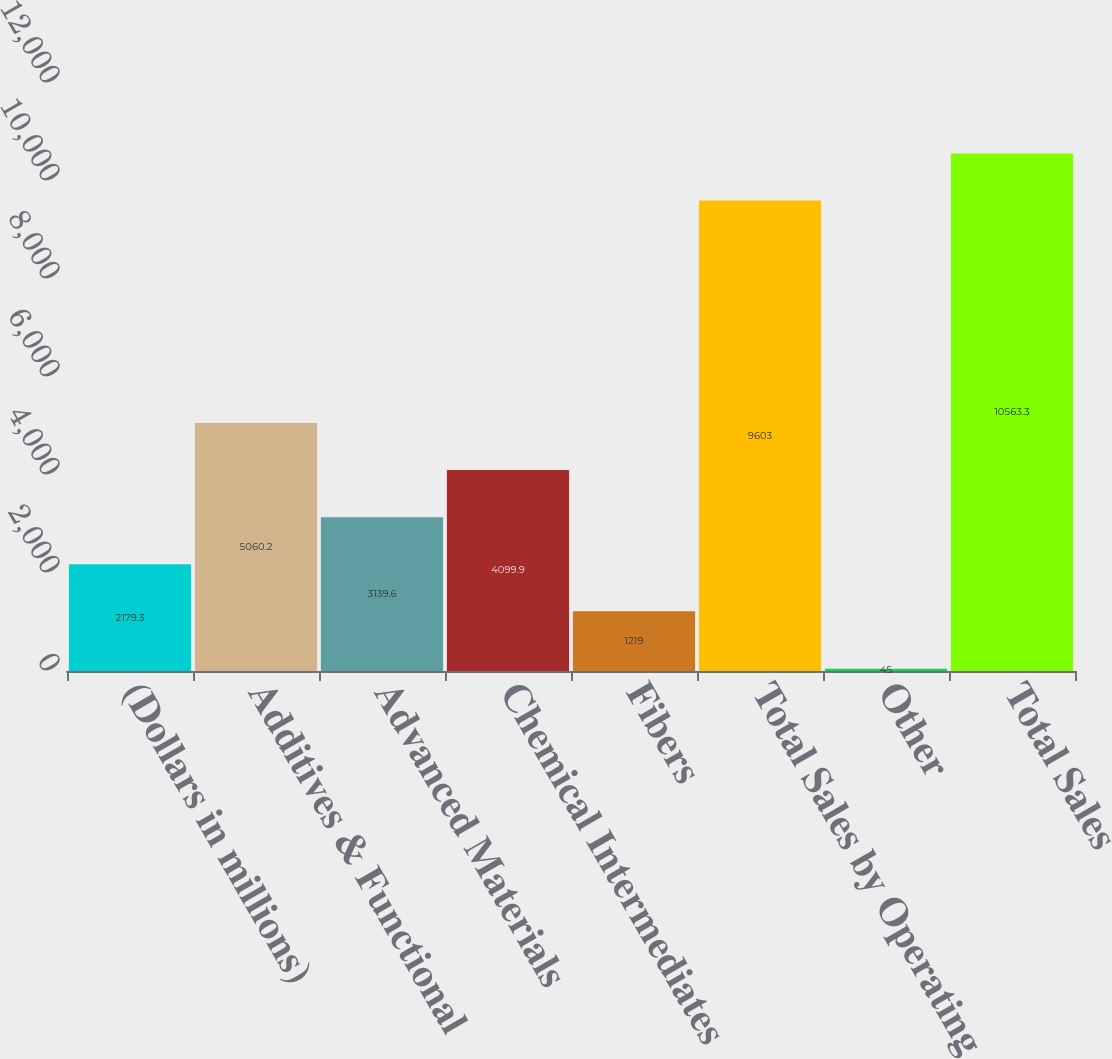Convert chart. <chart><loc_0><loc_0><loc_500><loc_500><bar_chart><fcel>(Dollars in millions)<fcel>Additives & Functional<fcel>Advanced Materials<fcel>Chemical Intermediates<fcel>Fibers<fcel>Total Sales by Operating<fcel>Other<fcel>Total Sales<nl><fcel>2179.3<fcel>5060.2<fcel>3139.6<fcel>4099.9<fcel>1219<fcel>9603<fcel>45<fcel>10563.3<nl></chart> 